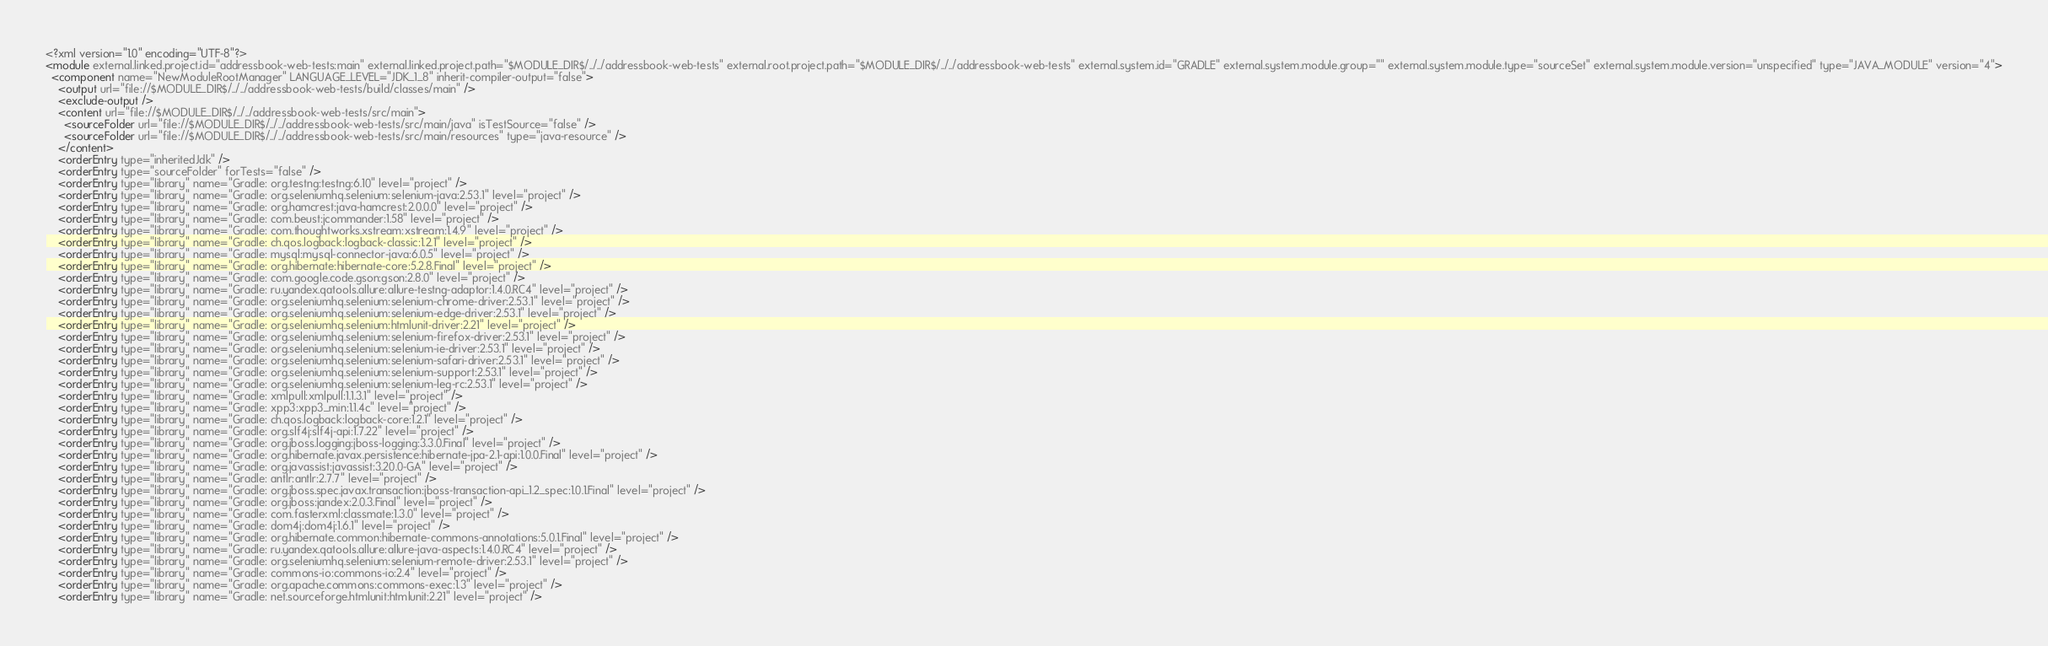Convert code to text. <code><loc_0><loc_0><loc_500><loc_500><_XML_><?xml version="1.0" encoding="UTF-8"?>
<module external.linked.project.id="addressbook-web-tests:main" external.linked.project.path="$MODULE_DIR$/../../addressbook-web-tests" external.root.project.path="$MODULE_DIR$/../../addressbook-web-tests" external.system.id="GRADLE" external.system.module.group="" external.system.module.type="sourceSet" external.system.module.version="unspecified" type="JAVA_MODULE" version="4">
  <component name="NewModuleRootManager" LANGUAGE_LEVEL="JDK_1_8" inherit-compiler-output="false">
    <output url="file://$MODULE_DIR$/../../addressbook-web-tests/build/classes/main" />
    <exclude-output />
    <content url="file://$MODULE_DIR$/../../addressbook-web-tests/src/main">
      <sourceFolder url="file://$MODULE_DIR$/../../addressbook-web-tests/src/main/java" isTestSource="false" />
      <sourceFolder url="file://$MODULE_DIR$/../../addressbook-web-tests/src/main/resources" type="java-resource" />
    </content>
    <orderEntry type="inheritedJdk" />
    <orderEntry type="sourceFolder" forTests="false" />
    <orderEntry type="library" name="Gradle: org.testng:testng:6.10" level="project" />
    <orderEntry type="library" name="Gradle: org.seleniumhq.selenium:selenium-java:2.53.1" level="project" />
    <orderEntry type="library" name="Gradle: org.hamcrest:java-hamcrest:2.0.0.0" level="project" />
    <orderEntry type="library" name="Gradle: com.beust:jcommander:1.58" level="project" />
    <orderEntry type="library" name="Gradle: com.thoughtworks.xstream:xstream:1.4.9" level="project" />
    <orderEntry type="library" name="Gradle: ch.qos.logback:logback-classic:1.2.1" level="project" />
    <orderEntry type="library" name="Gradle: mysql:mysql-connector-java:6.0.5" level="project" />
    <orderEntry type="library" name="Gradle: org.hibernate:hibernate-core:5.2.8.Final" level="project" />
    <orderEntry type="library" name="Gradle: com.google.code.gson:gson:2.8.0" level="project" />
    <orderEntry type="library" name="Gradle: ru.yandex.qatools.allure:allure-testng-adaptor:1.4.0.RC4" level="project" />
    <orderEntry type="library" name="Gradle: org.seleniumhq.selenium:selenium-chrome-driver:2.53.1" level="project" />
    <orderEntry type="library" name="Gradle: org.seleniumhq.selenium:selenium-edge-driver:2.53.1" level="project" />
    <orderEntry type="library" name="Gradle: org.seleniumhq.selenium:htmlunit-driver:2.21" level="project" />
    <orderEntry type="library" name="Gradle: org.seleniumhq.selenium:selenium-firefox-driver:2.53.1" level="project" />
    <orderEntry type="library" name="Gradle: org.seleniumhq.selenium:selenium-ie-driver:2.53.1" level="project" />
    <orderEntry type="library" name="Gradle: org.seleniumhq.selenium:selenium-safari-driver:2.53.1" level="project" />
    <orderEntry type="library" name="Gradle: org.seleniumhq.selenium:selenium-support:2.53.1" level="project" />
    <orderEntry type="library" name="Gradle: org.seleniumhq.selenium:selenium-leg-rc:2.53.1" level="project" />
    <orderEntry type="library" name="Gradle: xmlpull:xmlpull:1.1.3.1" level="project" />
    <orderEntry type="library" name="Gradle: xpp3:xpp3_min:1.1.4c" level="project" />
    <orderEntry type="library" name="Gradle: ch.qos.logback:logback-core:1.2.1" level="project" />
    <orderEntry type="library" name="Gradle: org.slf4j:slf4j-api:1.7.22" level="project" />
    <orderEntry type="library" name="Gradle: org.jboss.logging:jboss-logging:3.3.0.Final" level="project" />
    <orderEntry type="library" name="Gradle: org.hibernate.javax.persistence:hibernate-jpa-2.1-api:1.0.0.Final" level="project" />
    <orderEntry type="library" name="Gradle: org.javassist:javassist:3.20.0-GA" level="project" />
    <orderEntry type="library" name="Gradle: antlr:antlr:2.7.7" level="project" />
    <orderEntry type="library" name="Gradle: org.jboss.spec.javax.transaction:jboss-transaction-api_1.2_spec:1.0.1.Final" level="project" />
    <orderEntry type="library" name="Gradle: org.jboss:jandex:2.0.3.Final" level="project" />
    <orderEntry type="library" name="Gradle: com.fasterxml:classmate:1.3.0" level="project" />
    <orderEntry type="library" name="Gradle: dom4j:dom4j:1.6.1" level="project" />
    <orderEntry type="library" name="Gradle: org.hibernate.common:hibernate-commons-annotations:5.0.1.Final" level="project" />
    <orderEntry type="library" name="Gradle: ru.yandex.qatools.allure:allure-java-aspects:1.4.0.RC4" level="project" />
    <orderEntry type="library" name="Gradle: org.seleniumhq.selenium:selenium-remote-driver:2.53.1" level="project" />
    <orderEntry type="library" name="Gradle: commons-io:commons-io:2.4" level="project" />
    <orderEntry type="library" name="Gradle: org.apache.commons:commons-exec:1.3" level="project" />
    <orderEntry type="library" name="Gradle: net.sourceforge.htmlunit:htmlunit:2.21" level="project" /></code> 